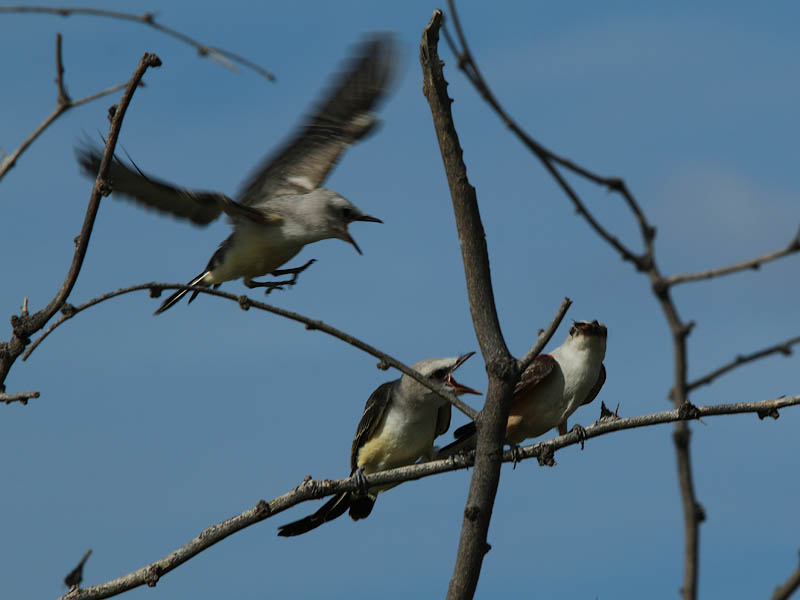Can you infer what type of birds these are and does their species provide insight into their behavior? While a species identification cannot be made with certainty without clearer visual characteristics, these birds could belong to a species that practices cooperative breeding or communal care. This behavior includes sibling birds helping to feed younger members of the brood and is often seen in species like some swallows, corvids, and various passerines. Their behavior reflects complex social structures and evolved survival strategies. 